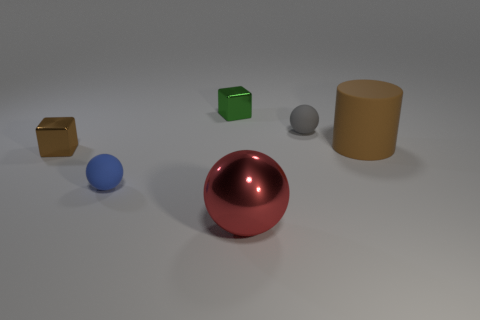Add 1 gray objects. How many objects exist? 7 Subtract all rubber spheres. How many spheres are left? 1 Subtract all cylinders. How many objects are left? 5 Subtract all cyan spheres. Subtract all cyan cylinders. How many spheres are left? 3 Subtract all tiny blue rubber objects. Subtract all small objects. How many objects are left? 1 Add 6 tiny blue things. How many tiny blue things are left? 7 Add 1 matte cylinders. How many matte cylinders exist? 2 Subtract 0 red cylinders. How many objects are left? 6 